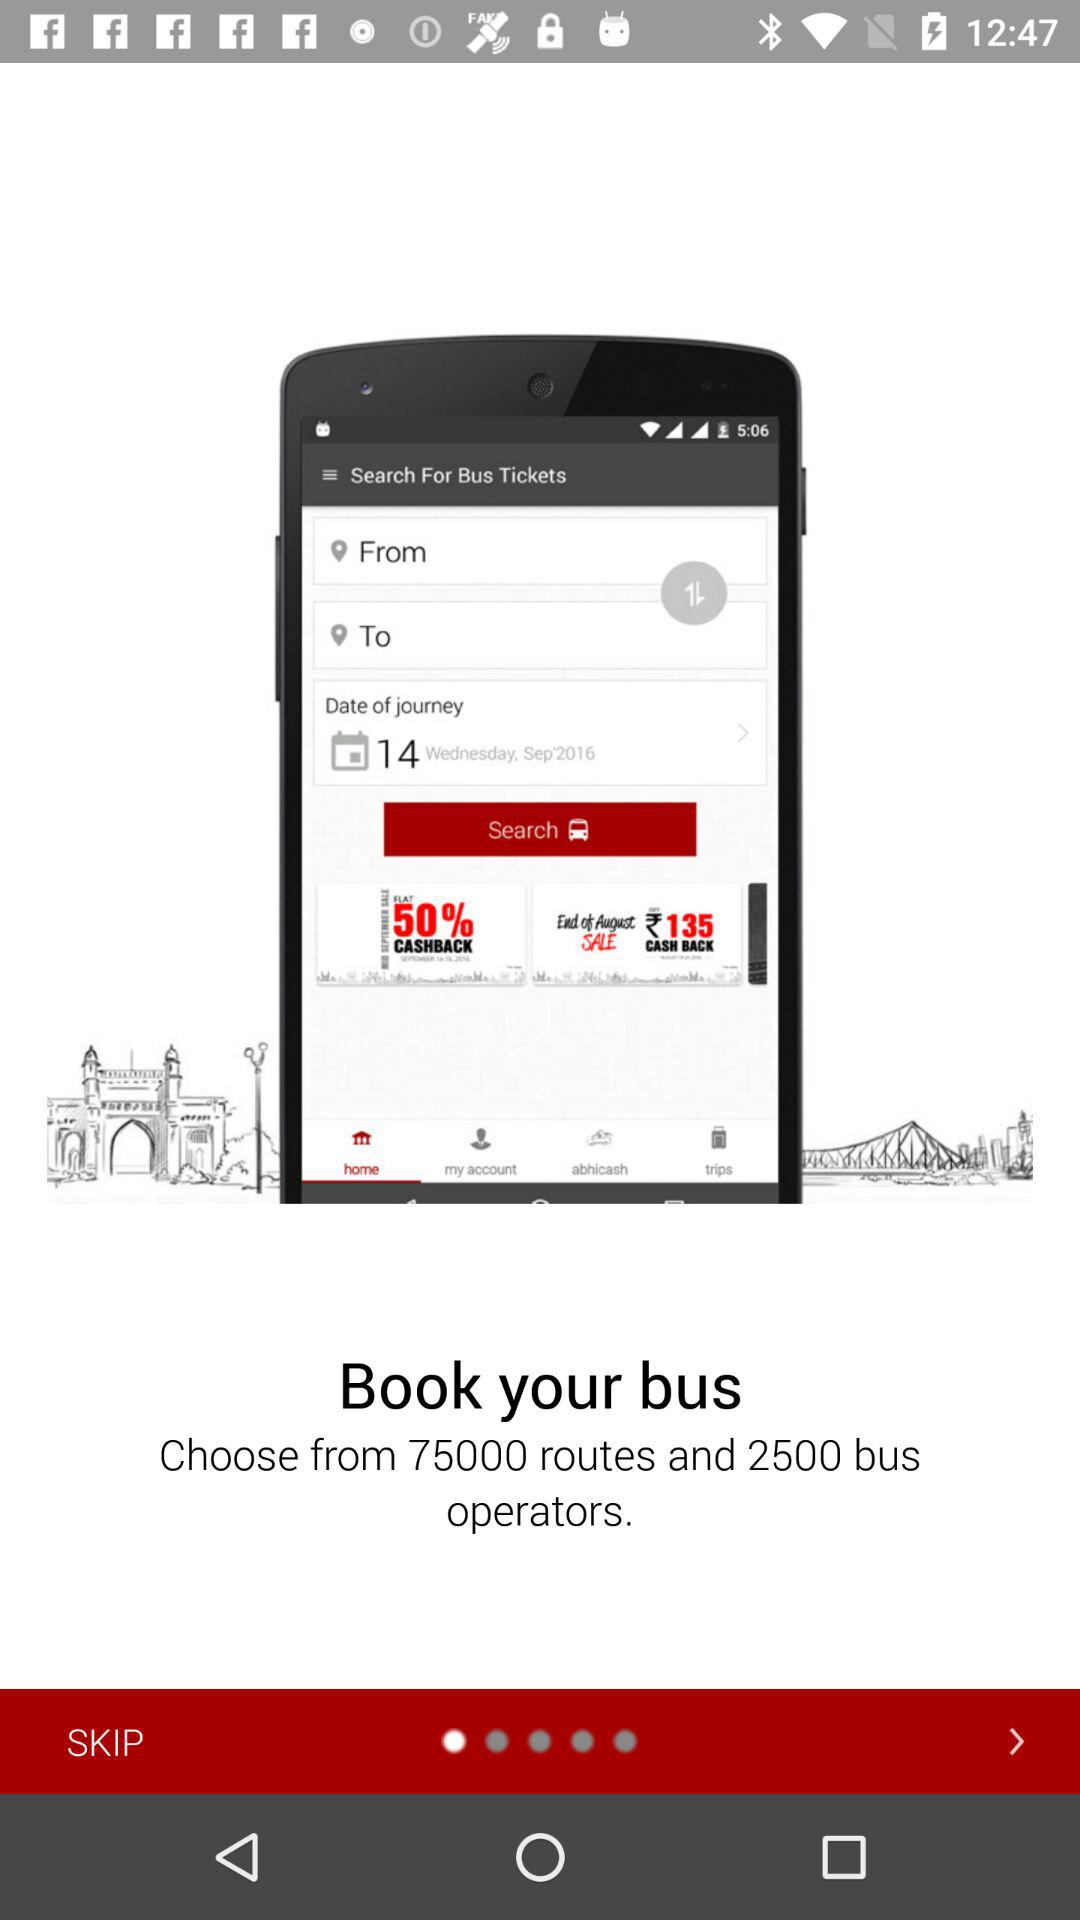How many bus operators are there? There are 2500 bus operators. 